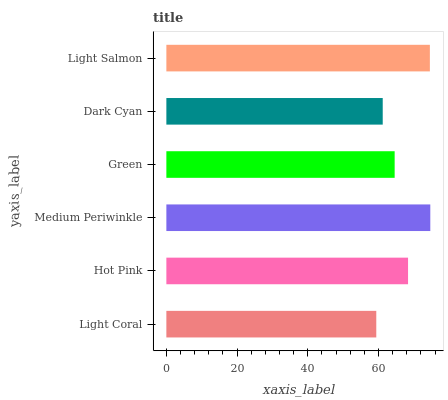Is Light Coral the minimum?
Answer yes or no. Yes. Is Medium Periwinkle the maximum?
Answer yes or no. Yes. Is Hot Pink the minimum?
Answer yes or no. No. Is Hot Pink the maximum?
Answer yes or no. No. Is Hot Pink greater than Light Coral?
Answer yes or no. Yes. Is Light Coral less than Hot Pink?
Answer yes or no. Yes. Is Light Coral greater than Hot Pink?
Answer yes or no. No. Is Hot Pink less than Light Coral?
Answer yes or no. No. Is Hot Pink the high median?
Answer yes or no. Yes. Is Green the low median?
Answer yes or no. Yes. Is Green the high median?
Answer yes or no. No. Is Dark Cyan the low median?
Answer yes or no. No. 